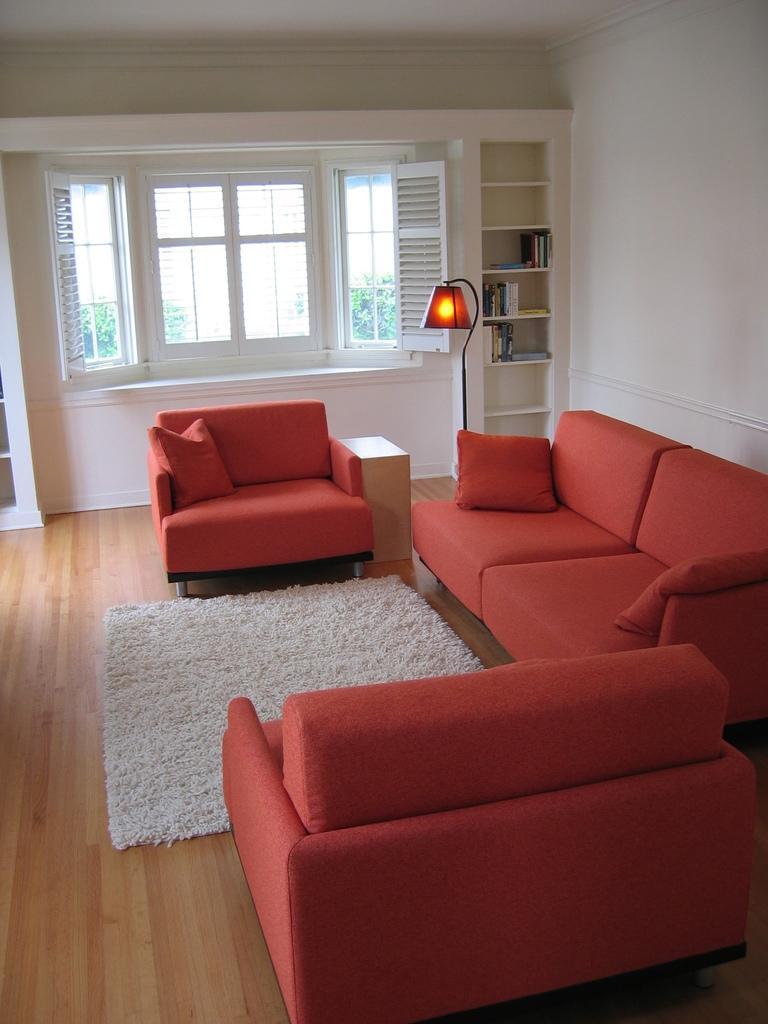Describe this image in one or two sentences. In this picture there is a couch near to the wall, beside the couch can see white carpet on the wooden floor. On the right there is a door near to the window. Beside the window we can see the shelf. In the shelf we can see many books. Beside that there is a lamp. Through the window we can see the plants and wall. 